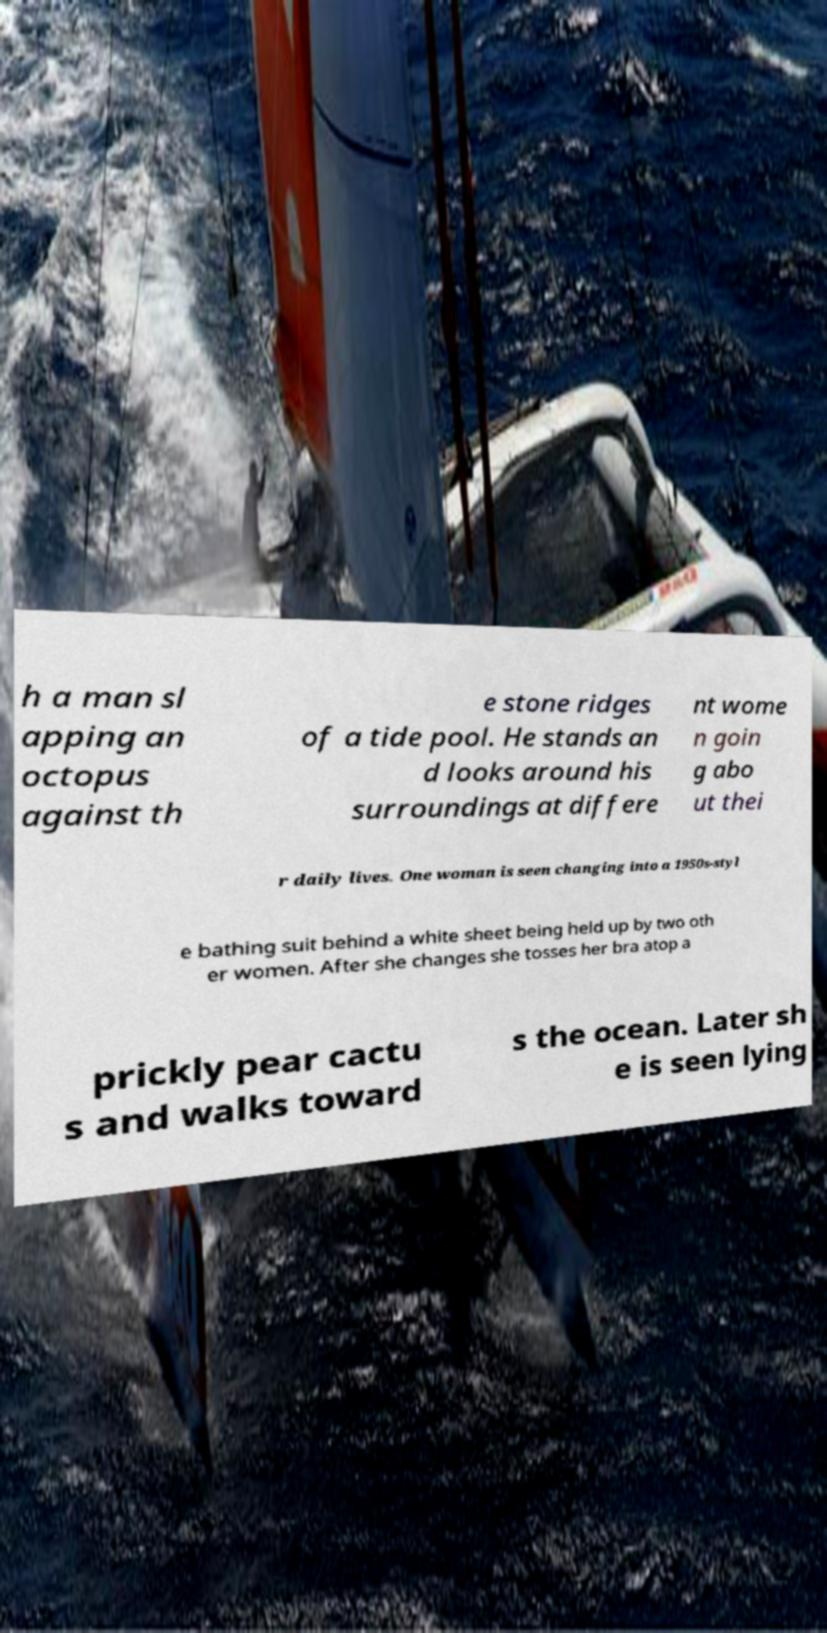Can you accurately transcribe the text from the provided image for me? h a man sl apping an octopus against th e stone ridges of a tide pool. He stands an d looks around his surroundings at differe nt wome n goin g abo ut thei r daily lives. One woman is seen changing into a 1950s-styl e bathing suit behind a white sheet being held up by two oth er women. After she changes she tosses her bra atop a prickly pear cactu s and walks toward s the ocean. Later sh e is seen lying 